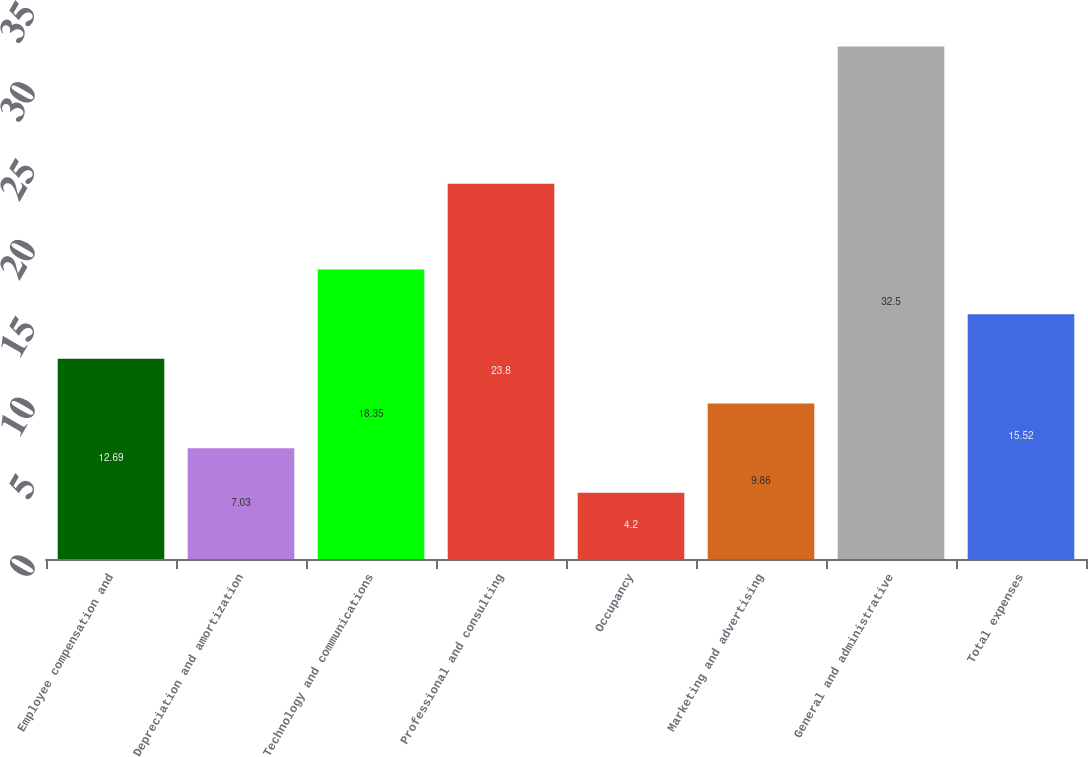<chart> <loc_0><loc_0><loc_500><loc_500><bar_chart><fcel>Employee compensation and<fcel>Depreciation and amortization<fcel>Technology and communications<fcel>Professional and consulting<fcel>Occupancy<fcel>Marketing and advertising<fcel>General and administrative<fcel>Total expenses<nl><fcel>12.69<fcel>7.03<fcel>18.35<fcel>23.8<fcel>4.2<fcel>9.86<fcel>32.5<fcel>15.52<nl></chart> 